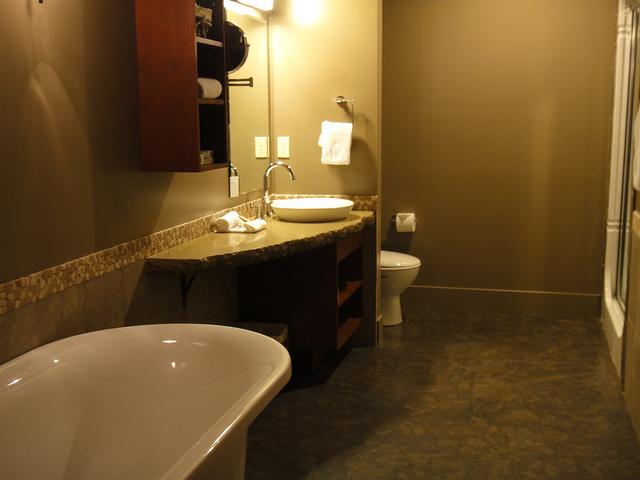Is this bathroom clean?
Answer briefly. Yes. Is there a tub?
Short answer required. Yes. What color is the sink faucet?
Give a very brief answer. Silver. 